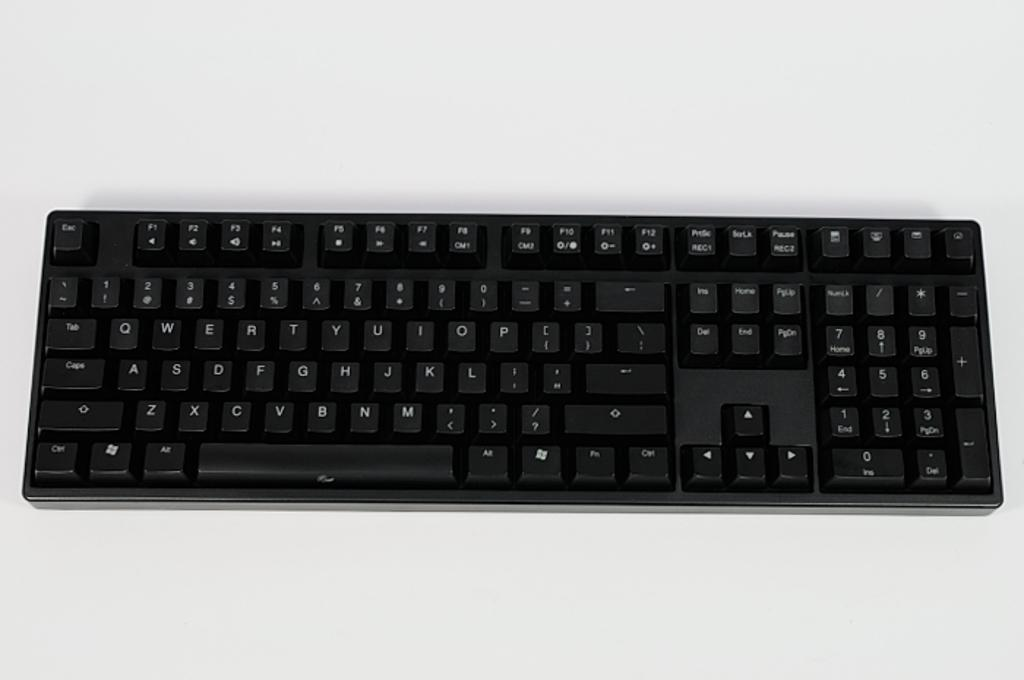What is the main object in the image? There is a keyboard in the image. What might the keyboard be used for? The keyboard is likely used for typing or inputting data. Can you describe the appearance of the keyboard? The image only shows a keyboard, so it is difficult to provide a detailed description of its appearance. How does the keyboard aid in the digestion process in the image? The keyboard does not aid in the digestion process, as it is an input device used for typing or data entry. 